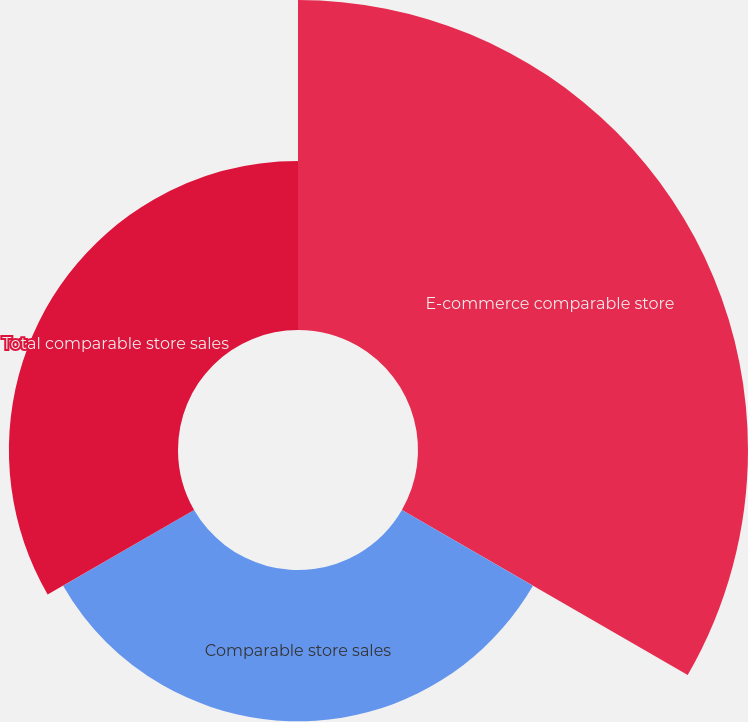Convert chart to OTSL. <chart><loc_0><loc_0><loc_500><loc_500><pie_chart><fcel>E-commerce comparable store<fcel>Comparable store sales<fcel>Total comparable store sales<nl><fcel>50.74%<fcel>23.26%<fcel>26.0%<nl></chart> 